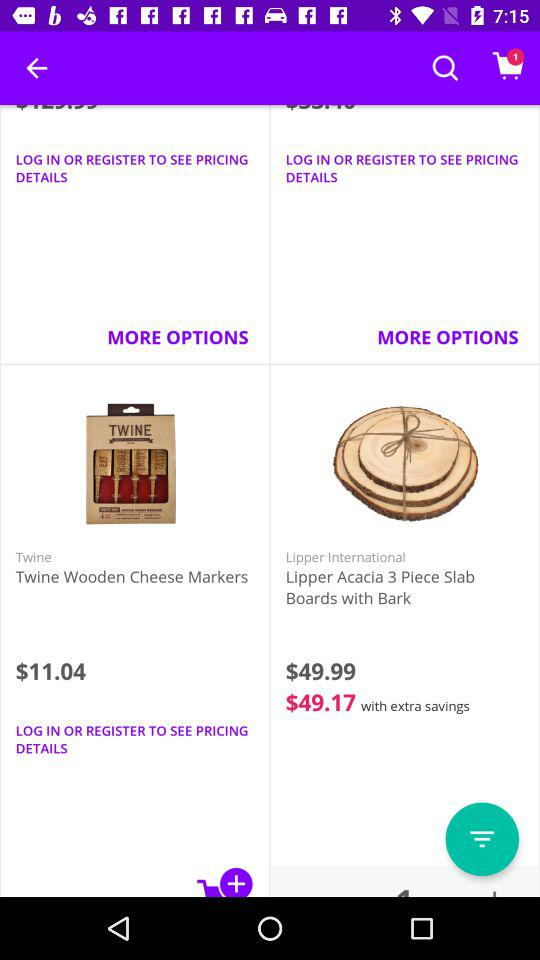What is the price of Lipper's acacia 3 piece slab boards with bark after discount? The price after discount is $49.17. 